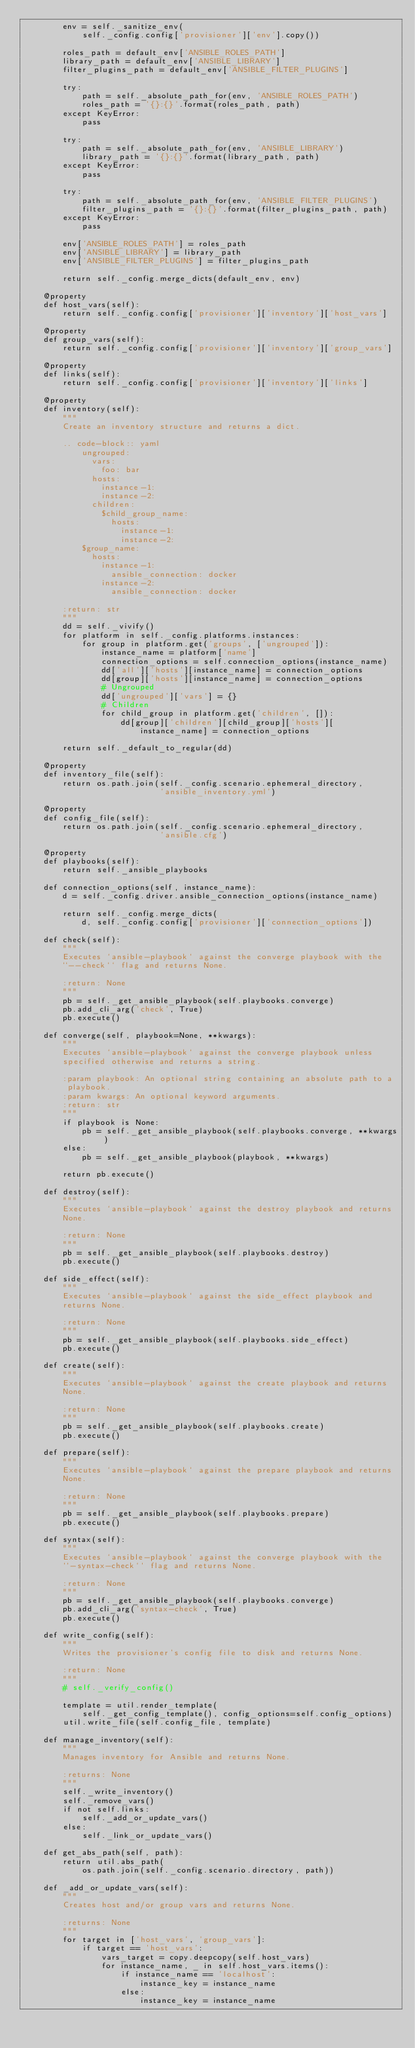Convert code to text. <code><loc_0><loc_0><loc_500><loc_500><_Python_>        env = self._sanitize_env(
            self._config.config['provisioner']['env'].copy())

        roles_path = default_env['ANSIBLE_ROLES_PATH']
        library_path = default_env['ANSIBLE_LIBRARY']
        filter_plugins_path = default_env['ANSIBLE_FILTER_PLUGINS']

        try:
            path = self._absolute_path_for(env, 'ANSIBLE_ROLES_PATH')
            roles_path = '{}:{}'.format(roles_path, path)
        except KeyError:
            pass

        try:
            path = self._absolute_path_for(env, 'ANSIBLE_LIBRARY')
            library_path = '{}:{}'.format(library_path, path)
        except KeyError:
            pass

        try:
            path = self._absolute_path_for(env, 'ANSIBLE_FILTER_PLUGINS')
            filter_plugins_path = '{}:{}'.format(filter_plugins_path, path)
        except KeyError:
            pass

        env['ANSIBLE_ROLES_PATH'] = roles_path
        env['ANSIBLE_LIBRARY'] = library_path
        env['ANSIBLE_FILTER_PLUGINS'] = filter_plugins_path

        return self._config.merge_dicts(default_env, env)

    @property
    def host_vars(self):
        return self._config.config['provisioner']['inventory']['host_vars']

    @property
    def group_vars(self):
        return self._config.config['provisioner']['inventory']['group_vars']

    @property
    def links(self):
        return self._config.config['provisioner']['inventory']['links']

    @property
    def inventory(self):
        """
        Create an inventory structure and returns a dict.

        .. code-block:: yaml
            ungrouped:
              vars:
                foo: bar
              hosts:
                instance-1:
                instance-2:
              children:
                $child_group_name:
                  hosts:
                    instance-1:
                    instance-2:
            $group_name:
              hosts:
                instance-1:
                  ansible_connection: docker
                instance-2:
                  ansible_connection: docker

        :return: str
        """
        dd = self._vivify()
        for platform in self._config.platforms.instances:
            for group in platform.get('groups', ['ungrouped']):
                instance_name = platform['name']
                connection_options = self.connection_options(instance_name)
                dd['all']['hosts'][instance_name] = connection_options
                dd[group]['hosts'][instance_name] = connection_options
                # Ungrouped
                dd['ungrouped']['vars'] = {}
                # Children
                for child_group in platform.get('children', []):
                    dd[group]['children'][child_group]['hosts'][
                        instance_name] = connection_options

        return self._default_to_regular(dd)

    @property
    def inventory_file(self):
        return os.path.join(self._config.scenario.ephemeral_directory,
                            'ansible_inventory.yml')

    @property
    def config_file(self):
        return os.path.join(self._config.scenario.ephemeral_directory,
                            'ansible.cfg')

    @property
    def playbooks(self):
        return self._ansible_playbooks

    def connection_options(self, instance_name):
        d = self._config.driver.ansible_connection_options(instance_name)

        return self._config.merge_dicts(
            d, self._config.config['provisioner']['connection_options'])

    def check(self):
        """
        Executes `ansible-playbook` against the converge playbook with the
        ``--check`` flag and returns None.

        :return: None
        """
        pb = self._get_ansible_playbook(self.playbooks.converge)
        pb.add_cli_arg('check', True)
        pb.execute()

    def converge(self, playbook=None, **kwargs):
        """
        Executes `ansible-playbook` against the converge playbook unless
        specified otherwise and returns a string.

        :param playbook: An optional string containing an absolute path to a
         playbook.
        :param kwargs: An optional keyword arguments.
        :return: str
        """
        if playbook is None:
            pb = self._get_ansible_playbook(self.playbooks.converge, **kwargs)
        else:
            pb = self._get_ansible_playbook(playbook, **kwargs)

        return pb.execute()

    def destroy(self):
        """
        Executes `ansible-playbook` against the destroy playbook and returns
        None.

        :return: None
        """
        pb = self._get_ansible_playbook(self.playbooks.destroy)
        pb.execute()

    def side_effect(self):
        """
        Executes `ansible-playbook` against the side_effect playbook and
        returns None.

        :return: None
        """
        pb = self._get_ansible_playbook(self.playbooks.side_effect)
        pb.execute()

    def create(self):
        """
        Executes `ansible-playbook` against the create playbook and returns
        None.

        :return: None
        """
        pb = self._get_ansible_playbook(self.playbooks.create)
        pb.execute()

    def prepare(self):
        """
        Executes `ansible-playbook` against the prepare playbook and returns
        None.

        :return: None
        """
        pb = self._get_ansible_playbook(self.playbooks.prepare)
        pb.execute()

    def syntax(self):
        """
        Executes `ansible-playbook` against the converge playbook with the
        ``-syntax-check`` flag and returns None.

        :return: None
        """
        pb = self._get_ansible_playbook(self.playbooks.converge)
        pb.add_cli_arg('syntax-check', True)
        pb.execute()

    def write_config(self):
        """
        Writes the provisioner's config file to disk and returns None.

        :return: None
        """
        # self._verify_config()

        template = util.render_template(
            self._get_config_template(), config_options=self.config_options)
        util.write_file(self.config_file, template)

    def manage_inventory(self):
        """
        Manages inventory for Ansible and returns None.

        :returns: None
        """
        self._write_inventory()
        self._remove_vars()
        if not self.links:
            self._add_or_update_vars()
        else:
            self._link_or_update_vars()

    def get_abs_path(self, path):
        return util.abs_path(
            os.path.join(self._config.scenario.directory, path))

    def _add_or_update_vars(self):
        """
        Creates host and/or group vars and returns None.

        :returns: None
        """
        for target in ['host_vars', 'group_vars']:
            if target == 'host_vars':
                vars_target = copy.deepcopy(self.host_vars)
                for instance_name, _ in self.host_vars.items():
                    if instance_name == 'localhost':
                        instance_key = instance_name
                    else:
                        instance_key = instance_name
</code> 